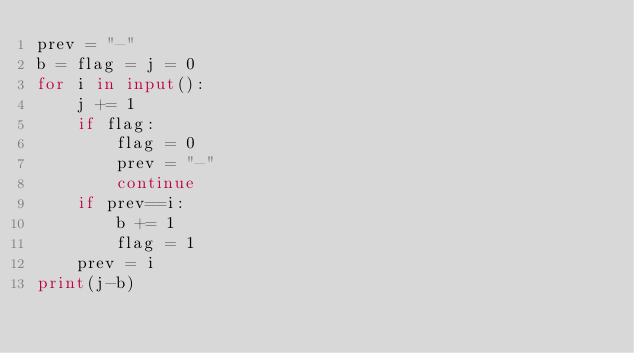Convert code to text. <code><loc_0><loc_0><loc_500><loc_500><_Python_>prev = "-"
b = flag = j = 0
for i in input():
    j += 1
    if flag:
        flag = 0
        prev = "-"
        continue
    if prev==i:
        b += 1
        flag = 1
    prev = i
print(j-b)</code> 